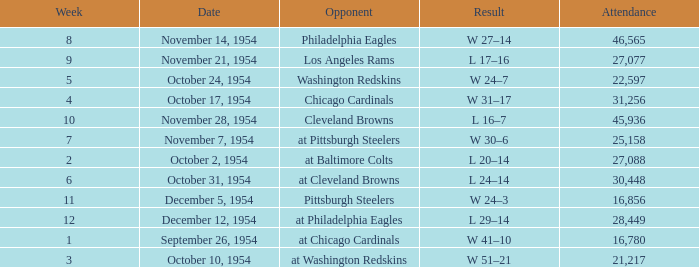How many weeks have october 31, 1954 as the date? 1.0. 